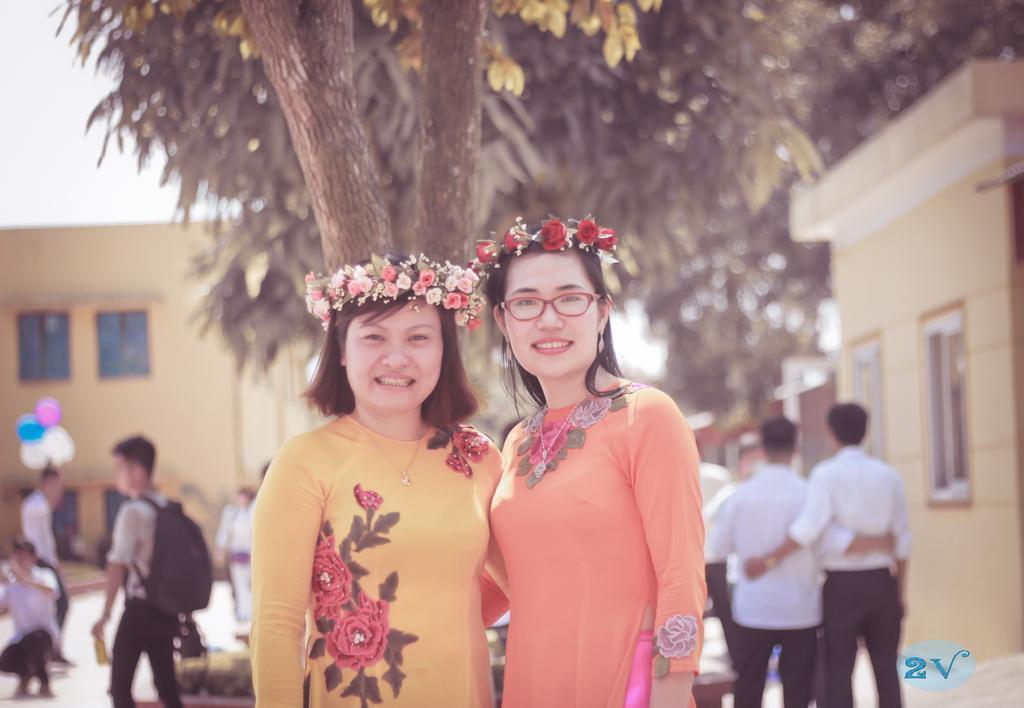Could you give a brief overview of what you see in this image? In the image we can see two women standing, wearing clothes, neck chain, flower crown and they are smiling. The right side woman is wearing spectacles and earrings. Behind them there are other people wearing clothes. Here we can see the balloon and trees. We can even see there are houses and the sky. The background is slightly blurred and on the bottom we can see the watermark. 